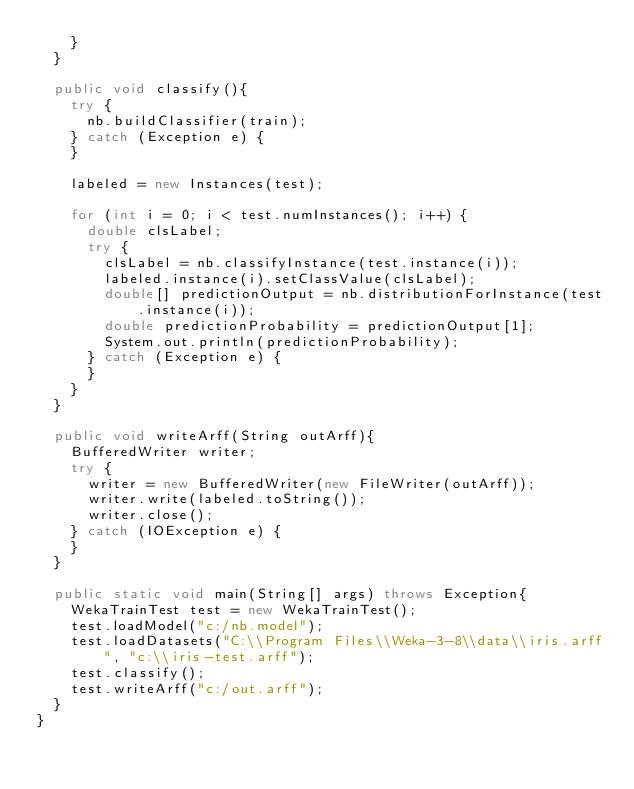<code> <loc_0><loc_0><loc_500><loc_500><_Java_>		}
	}

	public void classify(){
		try {
			nb.buildClassifier(train);
		} catch (Exception e) {
		}

		labeled = new Instances(test);

		for (int i = 0; i < test.numInstances(); i++) {
			double clsLabel;
			try {
				clsLabel = nb.classifyInstance(test.instance(i));
				labeled.instance(i).setClassValue(clsLabel);
				double[] predictionOutput = nb.distributionForInstance(test.instance(i));
				double predictionProbability = predictionOutput[1];
				System.out.println(predictionProbability);
			} catch (Exception e) {
			}
		}
	}

	public void writeArff(String outArff){
		BufferedWriter writer;
		try {
			writer = new BufferedWriter(new FileWriter(outArff));
			writer.write(labeled.toString());
			writer.close();
		} catch (IOException e) {
		}
	}
	
	public static void main(String[] args) throws Exception{
		WekaTrainTest test = new WekaTrainTest();
		test.loadModel("c:/nb.model");
		test.loadDatasets("C:\\Program Files\\Weka-3-8\\data\\iris.arff", "c:\\iris-test.arff");
		test.classify();
		test.writeArff("c:/out.arff");
	}
}
</code> 